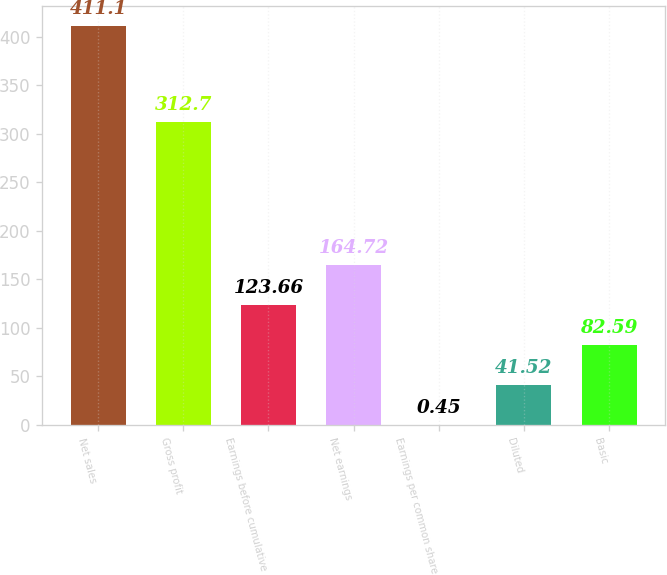Convert chart. <chart><loc_0><loc_0><loc_500><loc_500><bar_chart><fcel>Net sales<fcel>Gross profit<fcel>Earnings before cumulative<fcel>Net earnings<fcel>Earnings per common share<fcel>Diluted<fcel>Basic<nl><fcel>411.1<fcel>312.7<fcel>123.66<fcel>164.72<fcel>0.45<fcel>41.52<fcel>82.59<nl></chart> 